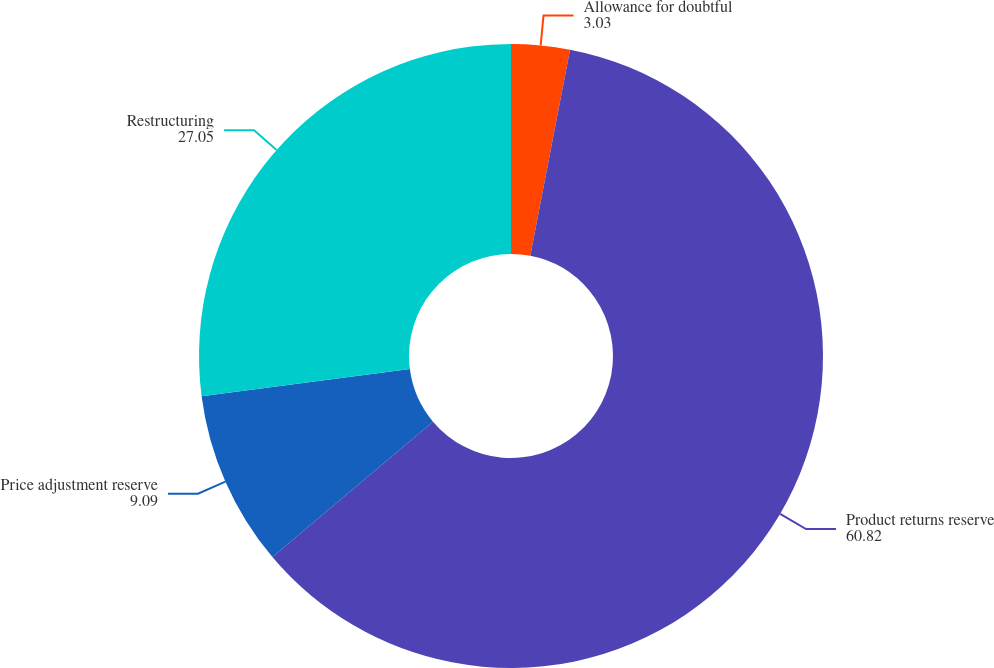Convert chart. <chart><loc_0><loc_0><loc_500><loc_500><pie_chart><fcel>Allowance for doubtful<fcel>Product returns reserve<fcel>Price adjustment reserve<fcel>Restructuring<nl><fcel>3.03%<fcel>60.82%<fcel>9.09%<fcel>27.05%<nl></chart> 